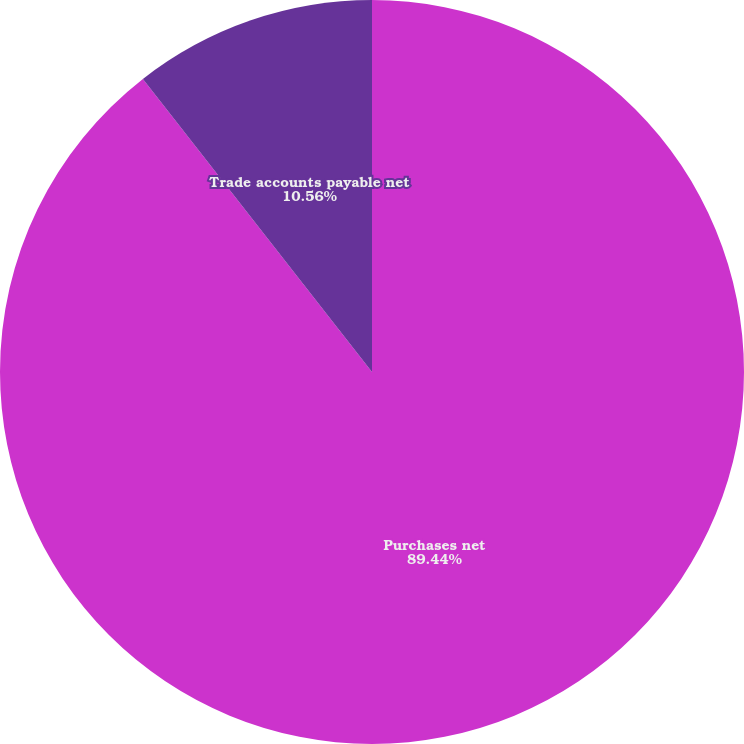Convert chart. <chart><loc_0><loc_0><loc_500><loc_500><pie_chart><fcel>Purchases net<fcel>Trade accounts payable net<nl><fcel>89.44%<fcel>10.56%<nl></chart> 